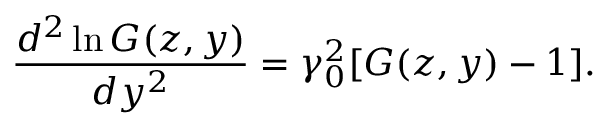<formula> <loc_0><loc_0><loc_500><loc_500>\frac { d ^ { 2 } \ln G ( z , y ) } { d y ^ { 2 } } = \gamma _ { 0 } ^ { 2 } [ G ( z , y ) - 1 ] .</formula> 